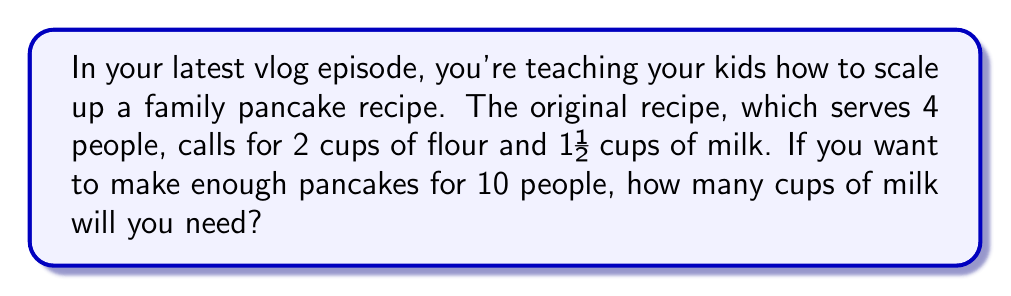What is the answer to this math problem? Let's solve this step-by-step:

1) First, we need to identify the ratio of people to milk in the original recipe:
   4 people : 1½ cups of milk

2) We can simplify this ratio by converting 1½ to an improper fraction:
   4 : $\frac{3}{2}$

3) Now, we want to find out how much milk we need for 10 people. We can set up a proportion:

   $\frac{4 \text{ people}}{\frac{3}{2} \text{ cups milk}} = \frac{10 \text{ people}}{x \text{ cups milk}}$

4) Cross multiply to solve for $x$:
   $4x = 10 \cdot \frac{3}{2}$

5) Simplify the right side:
   $4x = 15$

6) Divide both sides by 4:
   $x = \frac{15}{4} = 3.75$

Therefore, you will need 3.75 cups of milk for 10 people.
Answer: 3.75 cups 